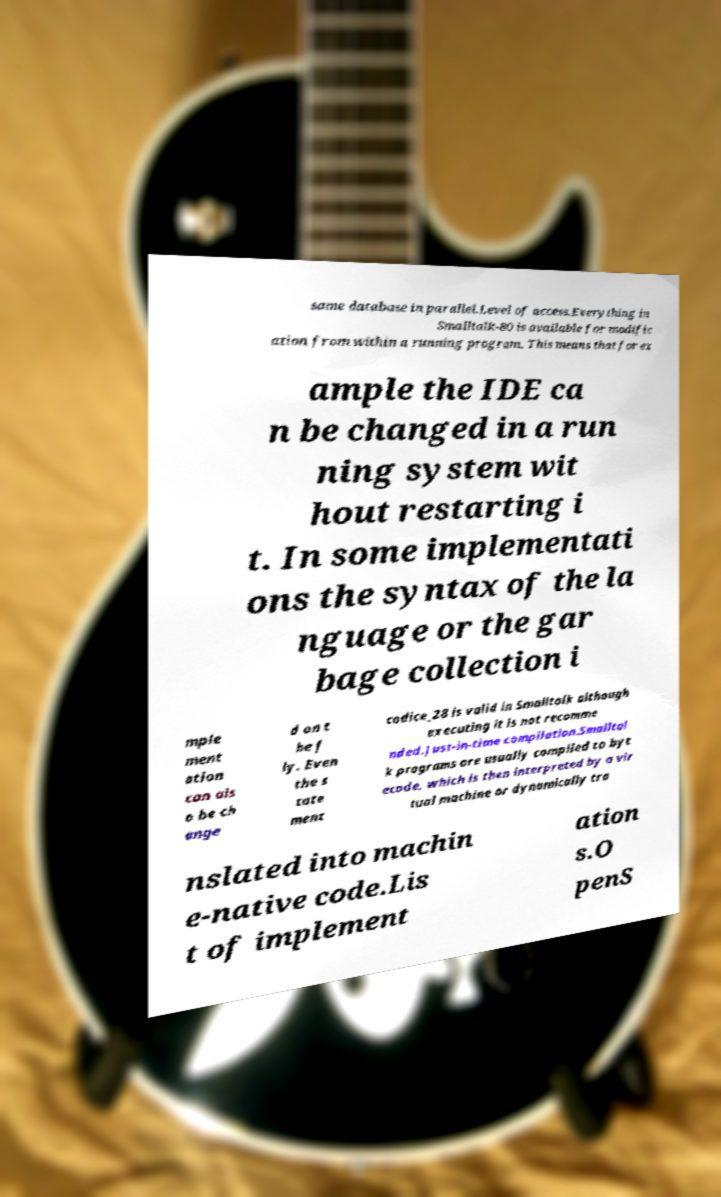Please read and relay the text visible in this image. What does it say? same database in parallel.Level of access.Everything in Smalltalk-80 is available for modific ation from within a running program. This means that for ex ample the IDE ca n be changed in a run ning system wit hout restarting i t. In some implementati ons the syntax of the la nguage or the gar bage collection i mple ment ation can als o be ch ange d on t he f ly. Even the s tate ment codice_28 is valid in Smalltalk although executing it is not recomme nded.Just-in-time compilation.Smalltal k programs are usually compiled to byt ecode, which is then interpreted by a vir tual machine or dynamically tra nslated into machin e-native code.Lis t of implement ation s.O penS 